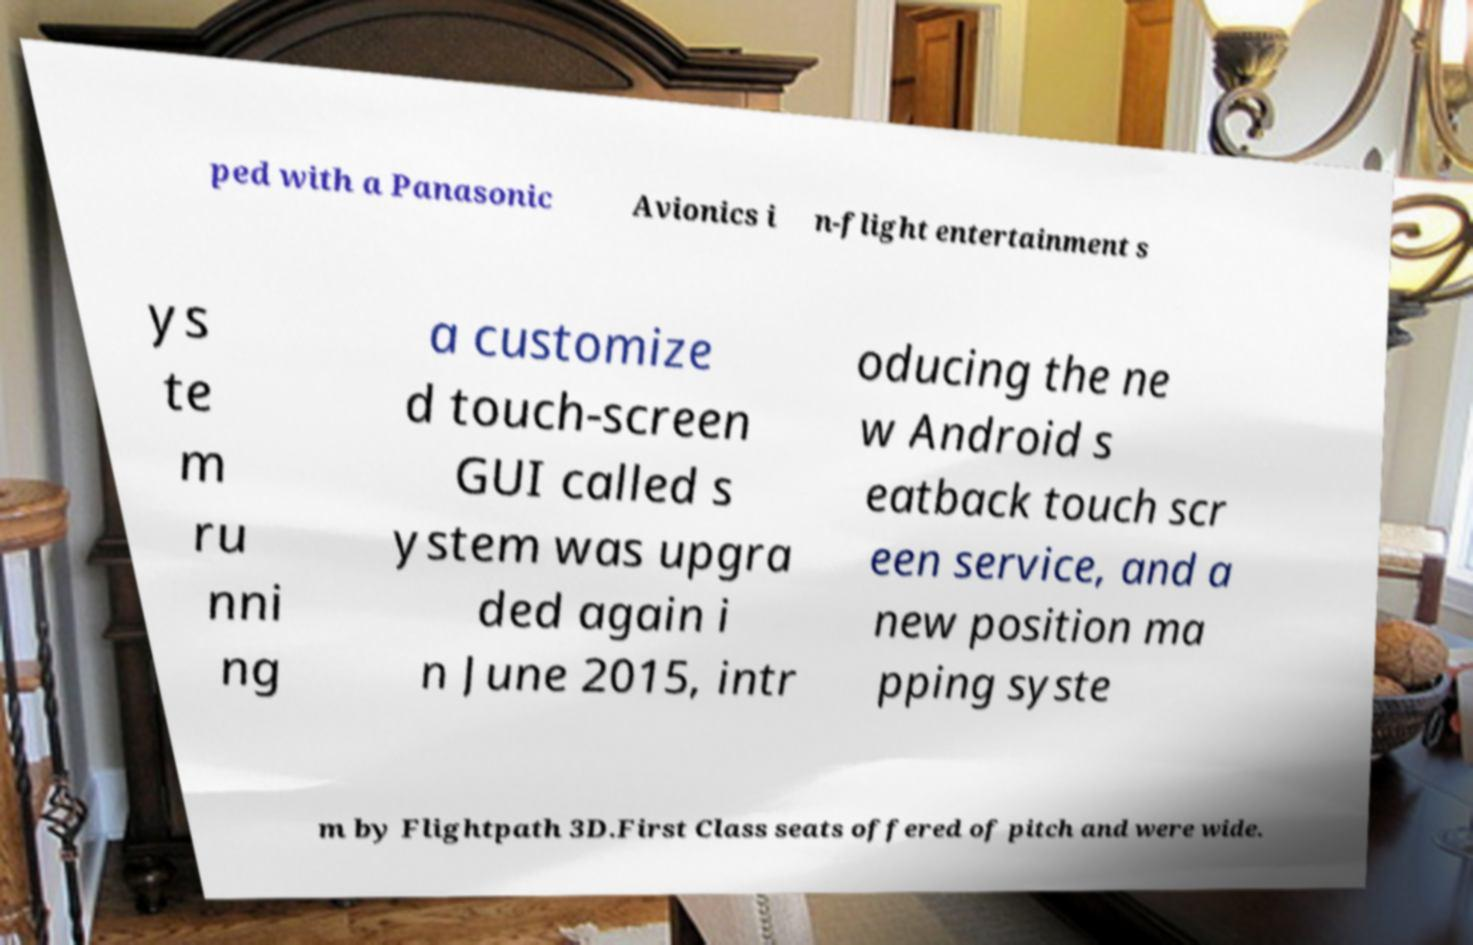I need the written content from this picture converted into text. Can you do that? ped with a Panasonic Avionics i n-flight entertainment s ys te m ru nni ng a customize d touch-screen GUI called s ystem was upgra ded again i n June 2015, intr oducing the ne w Android s eatback touch scr een service, and a new position ma pping syste m by Flightpath 3D.First Class seats offered of pitch and were wide. 